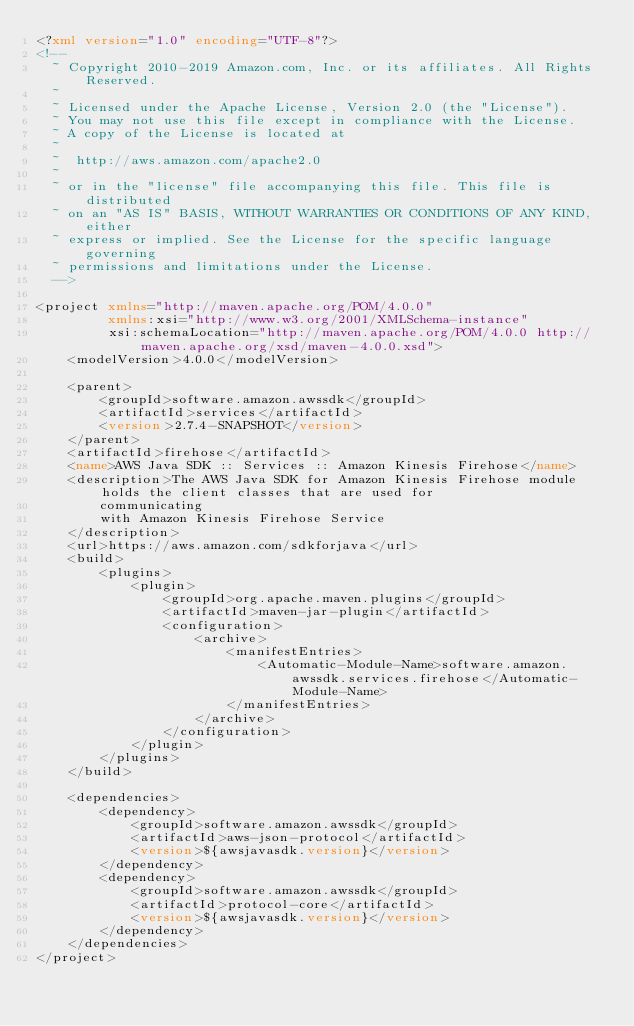<code> <loc_0><loc_0><loc_500><loc_500><_XML_><?xml version="1.0" encoding="UTF-8"?>
<!--
  ~ Copyright 2010-2019 Amazon.com, Inc. or its affiliates. All Rights Reserved.
  ~
  ~ Licensed under the Apache License, Version 2.0 (the "License").
  ~ You may not use this file except in compliance with the License.
  ~ A copy of the License is located at
  ~
  ~  http://aws.amazon.com/apache2.0
  ~
  ~ or in the "license" file accompanying this file. This file is distributed
  ~ on an "AS IS" BASIS, WITHOUT WARRANTIES OR CONDITIONS OF ANY KIND, either
  ~ express or implied. See the License for the specific language governing
  ~ permissions and limitations under the License.
  -->

<project xmlns="http://maven.apache.org/POM/4.0.0"
         xmlns:xsi="http://www.w3.org/2001/XMLSchema-instance"
         xsi:schemaLocation="http://maven.apache.org/POM/4.0.0 http://maven.apache.org/xsd/maven-4.0.0.xsd">
    <modelVersion>4.0.0</modelVersion>

    <parent>
        <groupId>software.amazon.awssdk</groupId>
        <artifactId>services</artifactId>
        <version>2.7.4-SNAPSHOT</version>
    </parent>
    <artifactId>firehose</artifactId>
    <name>AWS Java SDK :: Services :: Amazon Kinesis Firehose</name>
    <description>The AWS Java SDK for Amazon Kinesis Firehose module holds the client classes that are used for
        communicating
        with Amazon Kinesis Firehose Service
    </description>
    <url>https://aws.amazon.com/sdkforjava</url>
    <build>
        <plugins>
            <plugin>
                <groupId>org.apache.maven.plugins</groupId>
                <artifactId>maven-jar-plugin</artifactId>
                <configuration>
                    <archive>
                        <manifestEntries>
                            <Automatic-Module-Name>software.amazon.awssdk.services.firehose</Automatic-Module-Name>
                        </manifestEntries>
                    </archive>
                </configuration>
            </plugin>
        </plugins>
    </build>

    <dependencies>
        <dependency>
            <groupId>software.amazon.awssdk</groupId>
            <artifactId>aws-json-protocol</artifactId>
            <version>${awsjavasdk.version}</version>
        </dependency>
        <dependency>
            <groupId>software.amazon.awssdk</groupId>
            <artifactId>protocol-core</artifactId>
            <version>${awsjavasdk.version}</version>
        </dependency>
    </dependencies>
</project>
</code> 